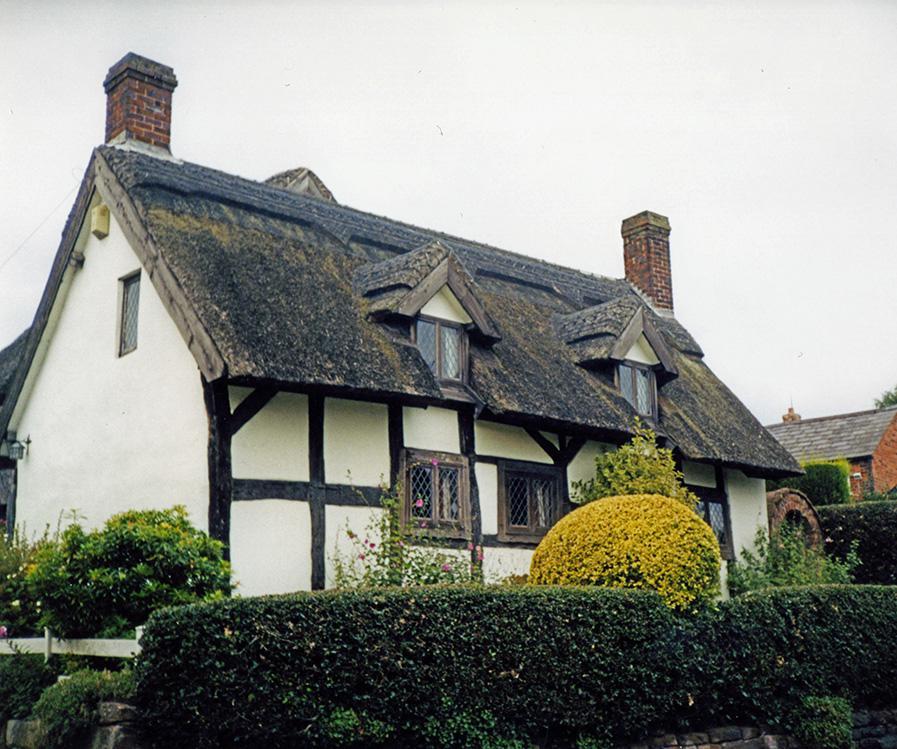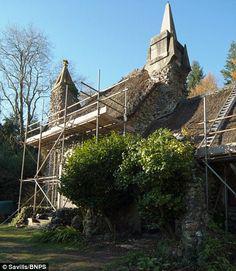The first image is the image on the left, the second image is the image on the right. Assess this claim about the two images: "The left image shows the front of a white house with bold dark lines on it forming geometric patterns, a chimney on at least one end, and a thick grayish peaked roof with a sculptural border along the top edge.". Correct or not? Answer yes or no. Yes. The first image is the image on the left, the second image is the image on the right. Given the left and right images, does the statement "In at least one image there is a white house with black stripes of wood that create a box look." hold true? Answer yes or no. Yes. 